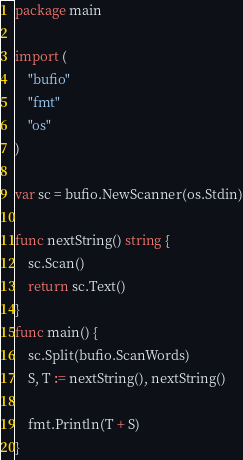<code> <loc_0><loc_0><loc_500><loc_500><_Go_>package main

import (
	"bufio"
	"fmt"
	"os"
)

var sc = bufio.NewScanner(os.Stdin)

func nextString() string {
	sc.Scan()
	return sc.Text()
}
func main() {
	sc.Split(bufio.ScanWords)
	S, T := nextString(), nextString()

	fmt.Println(T + S)
}
</code> 